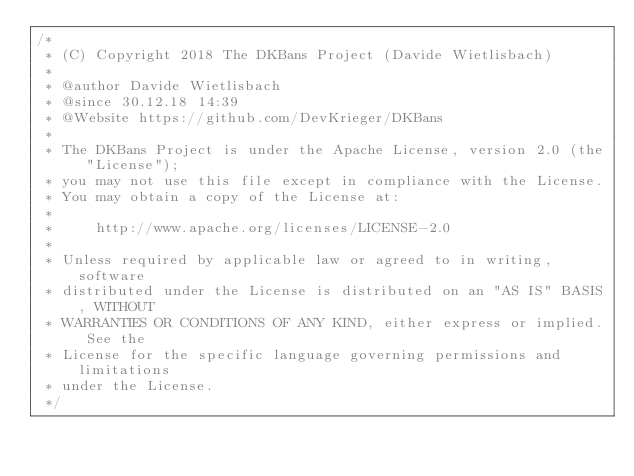Convert code to text. <code><loc_0><loc_0><loc_500><loc_500><_Java_>/*
 * (C) Copyright 2018 The DKBans Project (Davide Wietlisbach)
 *
 * @author Davide Wietlisbach
 * @since 30.12.18 14:39
 * @Website https://github.com/DevKrieger/DKBans
 *
 * The DKBans Project is under the Apache License, version 2.0 (the "License");
 * you may not use this file except in compliance with the License.
 * You may obtain a copy of the License at:
 *
 *     http://www.apache.org/licenses/LICENSE-2.0
 *
 * Unless required by applicable law or agreed to in writing, software
 * distributed under the License is distributed on an "AS IS" BASIS, WITHOUT
 * WARRANTIES OR CONDITIONS OF ANY KIND, either express or implied. See the
 * License for the specific language governing permissions and limitations
 * under the License.
 */
</code> 